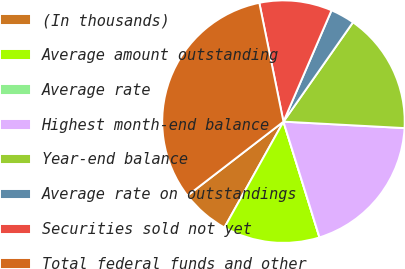Convert chart to OTSL. <chart><loc_0><loc_0><loc_500><loc_500><pie_chart><fcel>(In thousands)<fcel>Average amount outstanding<fcel>Average rate<fcel>Highest month-end balance<fcel>Year-end balance<fcel>Average rate on outstandings<fcel>Securities sold not yet<fcel>Total federal funds and other<nl><fcel>6.45%<fcel>12.9%<fcel>0.0%<fcel>19.35%<fcel>16.13%<fcel>3.23%<fcel>9.68%<fcel>32.26%<nl></chart> 